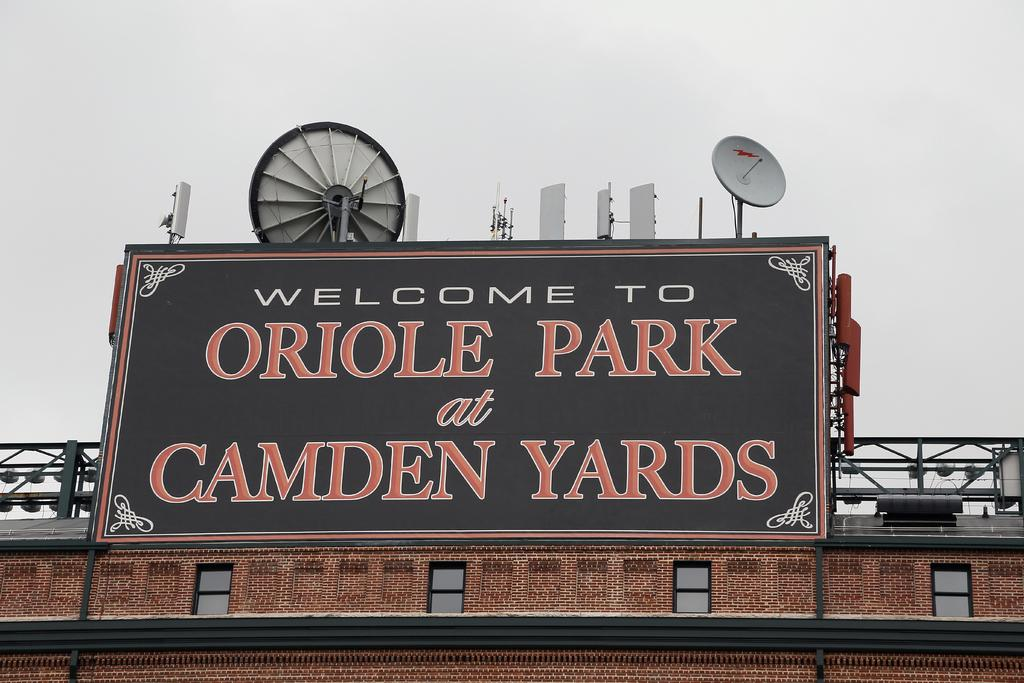<image>
Describe the image concisely. A city welcome sign sits on a building. 